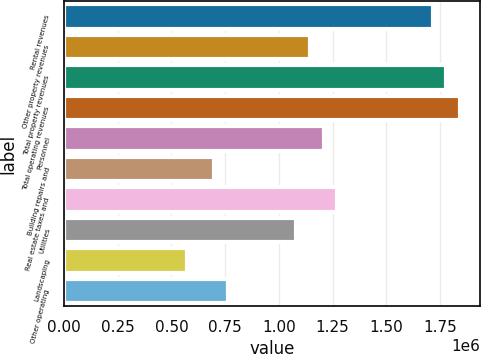Convert chart. <chart><loc_0><loc_0><loc_500><loc_500><bar_chart><fcel>Rental revenues<fcel>Other property revenues<fcel>Total property revenues<fcel>Total operating revenues<fcel>Personnel<fcel>Building repairs and<fcel>Real estate taxes and<fcel>Utilities<fcel>Landscaping<fcel>Other operating<nl><fcel>1.71582e+06<fcel>1.14388e+06<fcel>1.77937e+06<fcel>1.84292e+06<fcel>1.20743e+06<fcel>699039<fcel>1.27098e+06<fcel>1.08033e+06<fcel>571941<fcel>762588<nl></chart> 